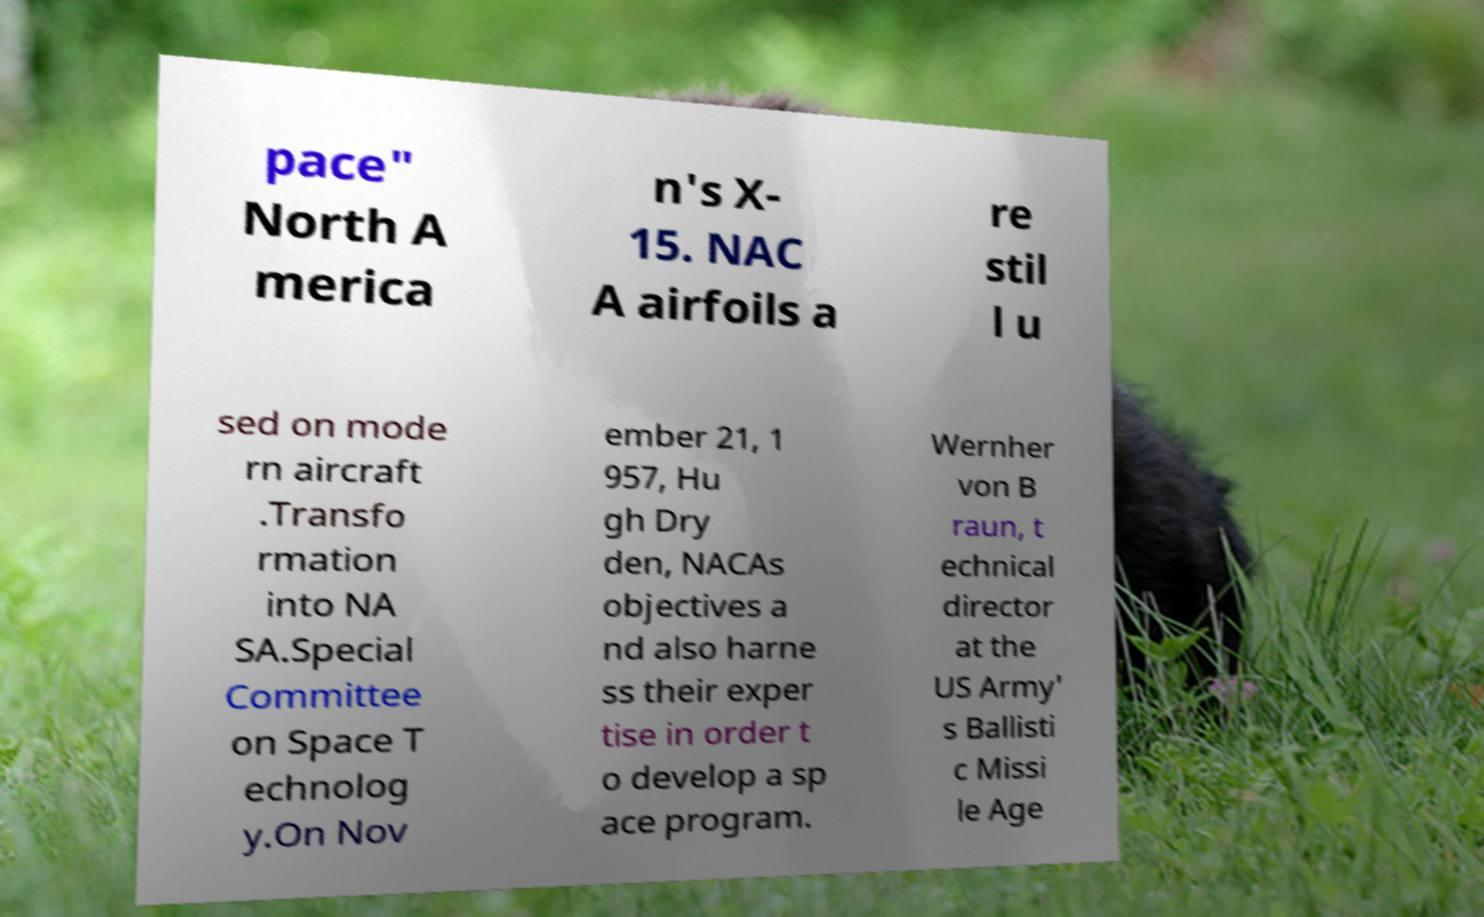Could you assist in decoding the text presented in this image and type it out clearly? pace" North A merica n's X- 15. NAC A airfoils a re stil l u sed on mode rn aircraft .Transfo rmation into NA SA.Special Committee on Space T echnolog y.On Nov ember 21, 1 957, Hu gh Dry den, NACAs objectives a nd also harne ss their exper tise in order t o develop a sp ace program. Wernher von B raun, t echnical director at the US Army' s Ballisti c Missi le Age 